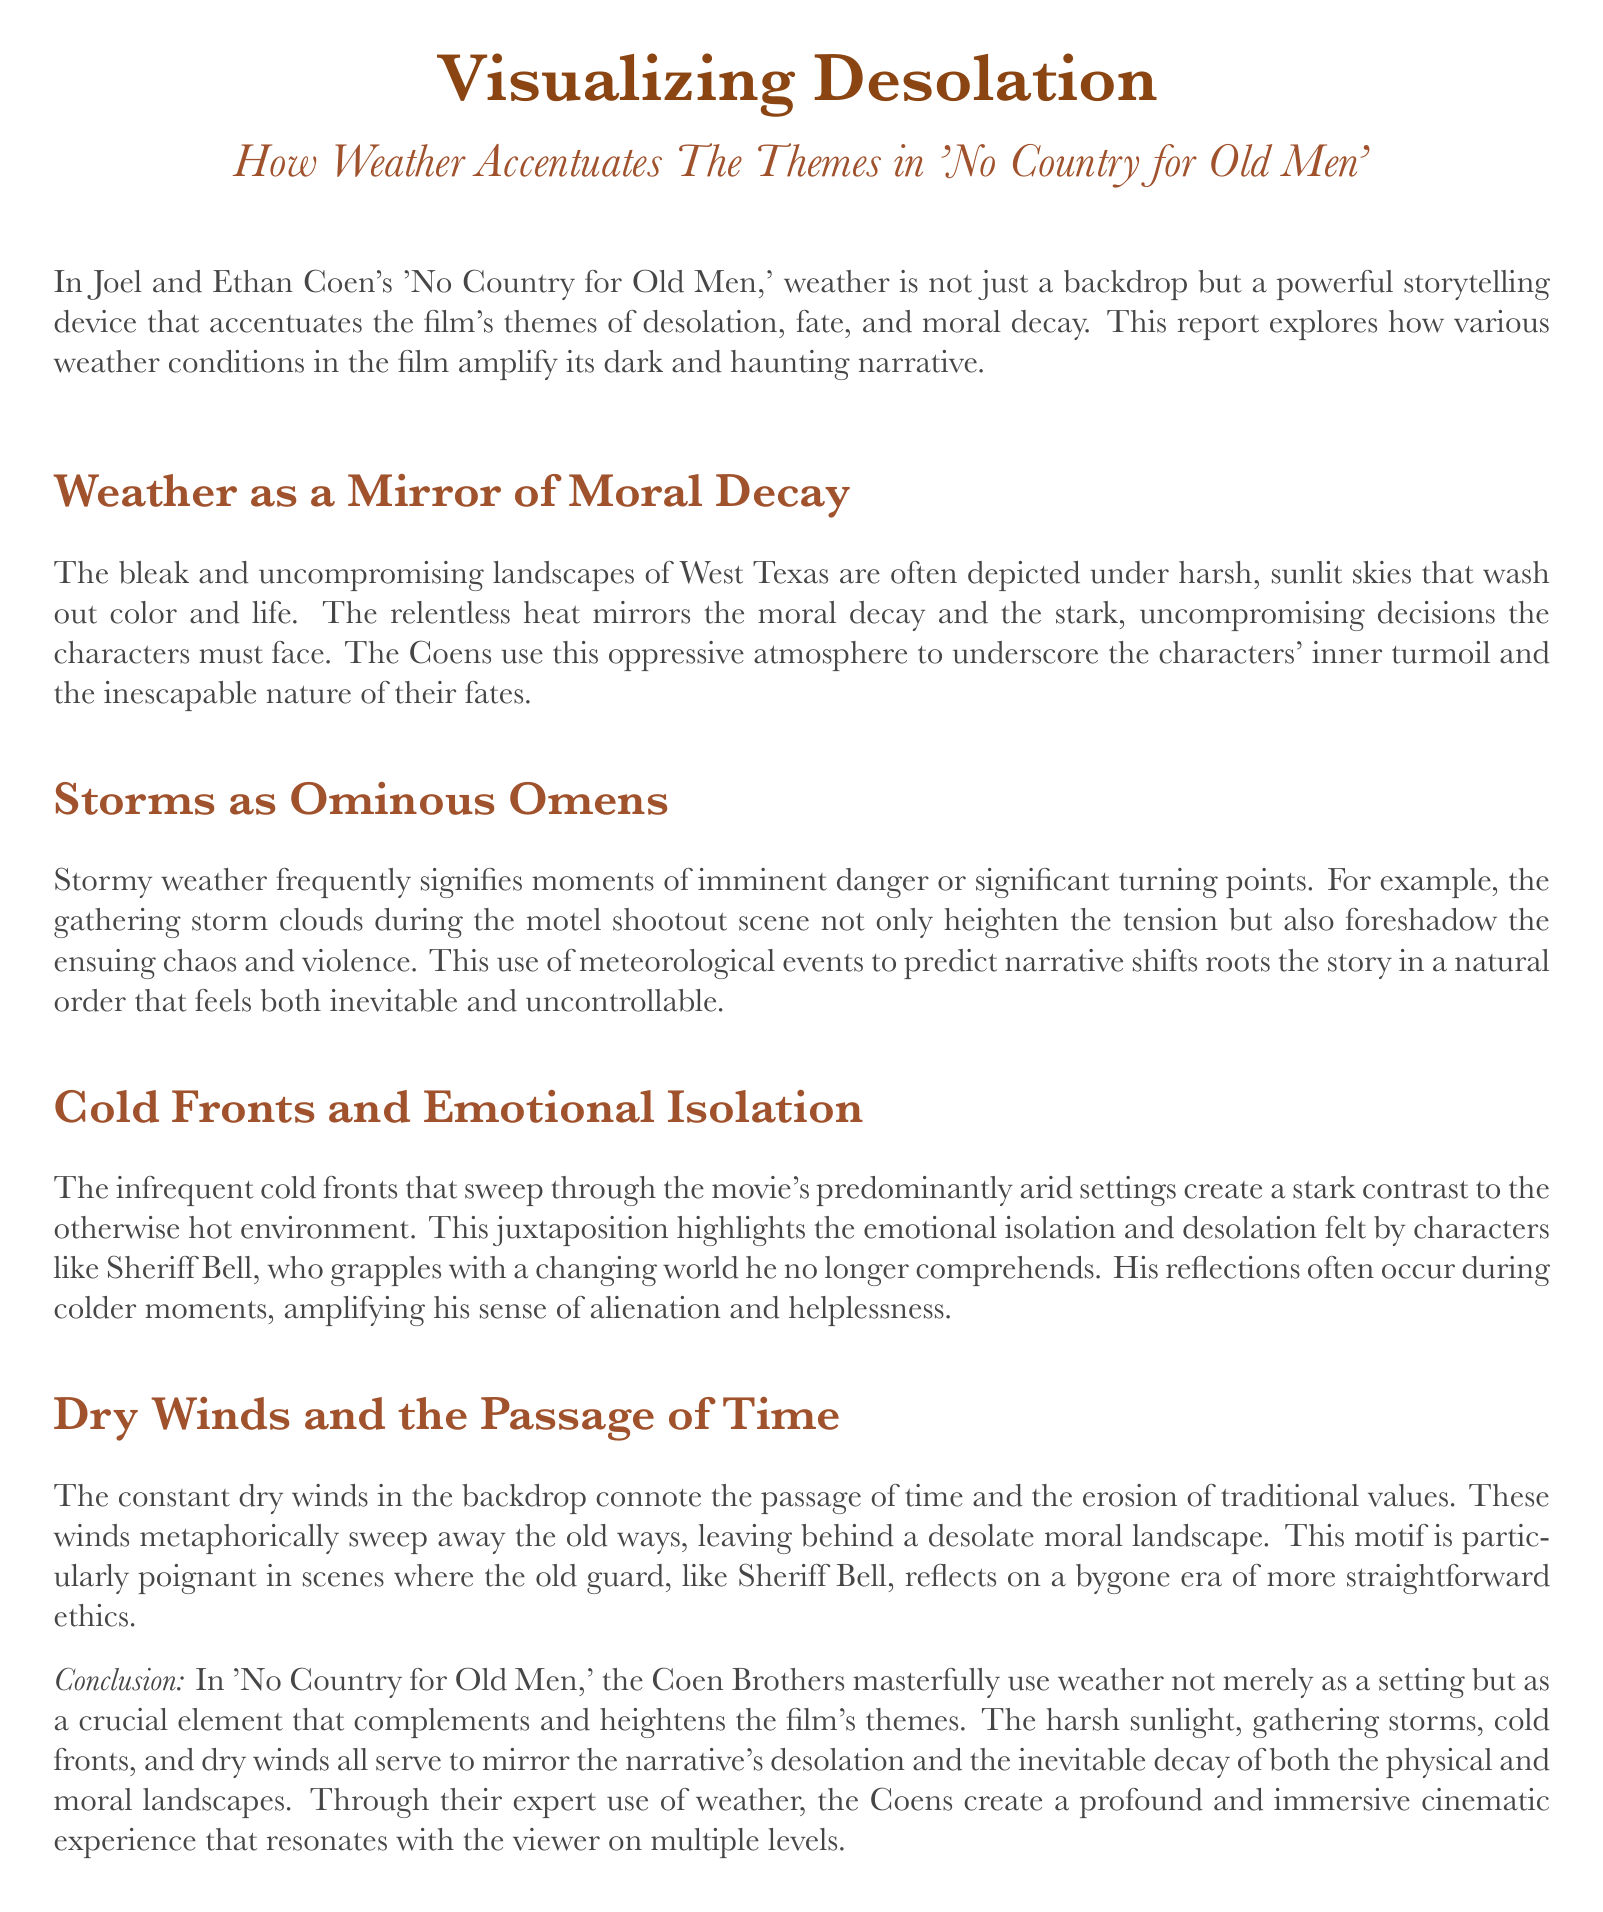what is the title of the report? The title is stated at the beginning of the document and is "Visualizing Desolation".
Answer: Visualizing Desolation who are the directors of 'No Country for Old Men'? The report mentions Joel and Ethan Coen as the directors.
Answer: Joel and Ethan Coen what does the constant dry winds connote? The document explains that dry winds connote the passage of time and the erosion of traditional values.
Answer: passage of time how do storms function in the narrative? The report describes storms as ominous omens that signify moments of imminent danger or significant turning points.
Answer: ominous omens which character grapples with a changing world? The document specifically mentions Sheriff Bell as the character grappling with a changing world.
Answer: Sheriff Bell what is the emotional state highlighted by cold fronts? The cold fronts highlight emotional isolation and desolation in the characters.
Answer: emotional isolation what kind of atmosphere does the relentless heat create? The document states that the relentless heat creates an oppressive atmosphere, highlighting moral decay.
Answer: oppressive atmosphere how do the Coen Brothers use weather in the film? The report concludes that the Coen Brothers use weather as a crucial element that complements the film's themes.
Answer: crucial element 